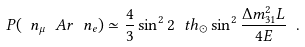Convert formula to latex. <formula><loc_0><loc_0><loc_500><loc_500>P ( \ n _ { \mu } \ A r \ n _ { e } ) \simeq \frac { 4 } { 3 } \sin ^ { 2 } 2 \ t h _ { \odot } \sin ^ { 2 } \frac { \Delta m _ { 3 1 } ^ { 2 } L } { 4 E } \ .</formula> 